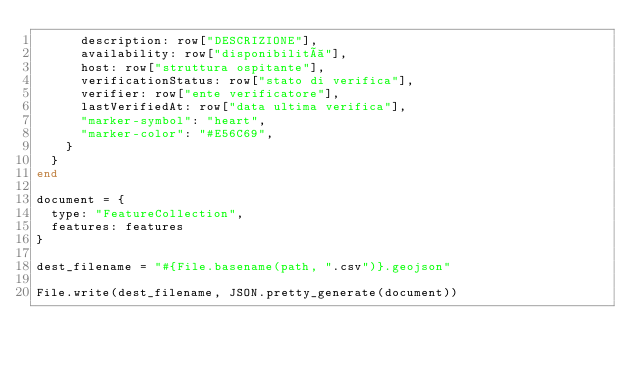<code> <loc_0><loc_0><loc_500><loc_500><_Ruby_>      description: row["DESCRIZIONE"],
      availability: row["disponibilità"],
      host: row["struttura ospitante"],
      verificationStatus: row["stato di verifica"],
      verifier: row["ente verificatore"],
      lastVerifiedAt: row["data ultima verifica"],
      "marker-symbol": "heart",
      "marker-color": "#E56C69",
    }
  }
end

document = {
  type: "FeatureCollection",
  features: features
}

dest_filename = "#{File.basename(path, ".csv")}.geojson"

File.write(dest_filename, JSON.pretty_generate(document))
</code> 